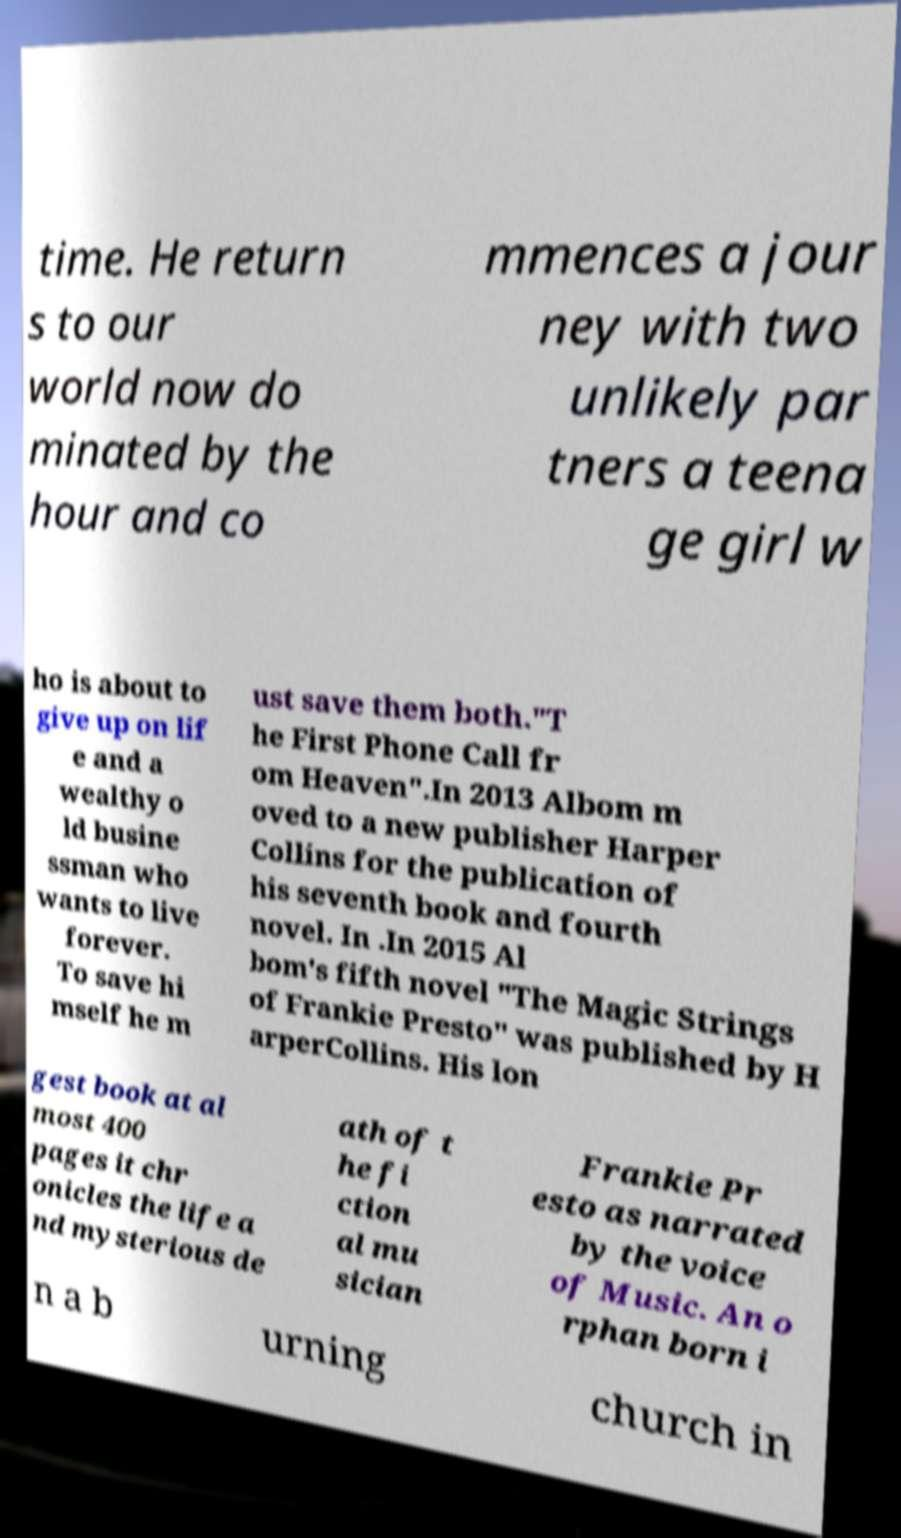I need the written content from this picture converted into text. Can you do that? time. He return s to our world now do minated by the hour and co mmences a jour ney with two unlikely par tners a teena ge girl w ho is about to give up on lif e and a wealthy o ld busine ssman who wants to live forever. To save hi mself he m ust save them both."T he First Phone Call fr om Heaven".In 2013 Albom m oved to a new publisher Harper Collins for the publication of his seventh book and fourth novel. In .In 2015 Al bom's fifth novel "The Magic Strings of Frankie Presto" was published by H arperCollins. His lon gest book at al most 400 pages it chr onicles the life a nd mysterious de ath of t he fi ction al mu sician Frankie Pr esto as narrated by the voice of Music. An o rphan born i n a b urning church in 